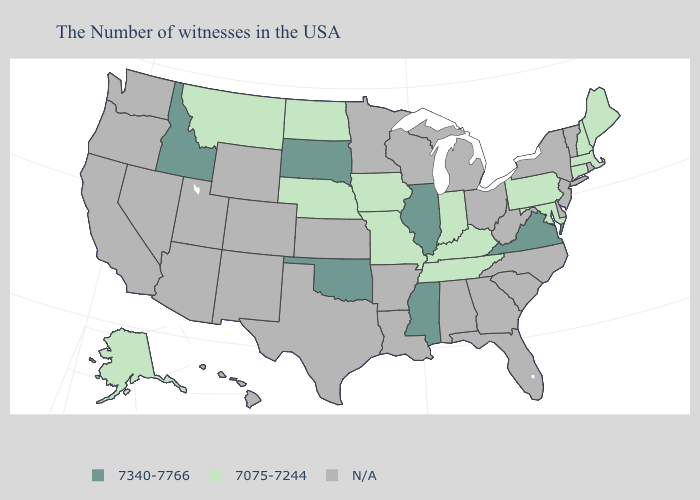What is the value of Vermont?
Keep it brief. N/A. Does the first symbol in the legend represent the smallest category?
Concise answer only. No. Name the states that have a value in the range N/A?
Write a very short answer. Rhode Island, Vermont, New York, New Jersey, Delaware, North Carolina, South Carolina, West Virginia, Ohio, Florida, Georgia, Michigan, Alabama, Wisconsin, Louisiana, Arkansas, Minnesota, Kansas, Texas, Wyoming, Colorado, New Mexico, Utah, Arizona, Nevada, California, Washington, Oregon, Hawaii. What is the highest value in the MidWest ?
Be succinct. 7340-7766. Does Montana have the lowest value in the West?
Concise answer only. Yes. Which states have the lowest value in the USA?
Quick response, please. Maine, Massachusetts, New Hampshire, Connecticut, Maryland, Pennsylvania, Kentucky, Indiana, Tennessee, Missouri, Iowa, Nebraska, North Dakota, Montana, Alaska. Which states have the lowest value in the USA?
Be succinct. Maine, Massachusetts, New Hampshire, Connecticut, Maryland, Pennsylvania, Kentucky, Indiana, Tennessee, Missouri, Iowa, Nebraska, North Dakota, Montana, Alaska. Which states have the lowest value in the South?
Short answer required. Maryland, Kentucky, Tennessee. What is the lowest value in the MidWest?
Write a very short answer. 7075-7244. What is the lowest value in the USA?
Keep it brief. 7075-7244. How many symbols are there in the legend?
Concise answer only. 3. Which states have the lowest value in the Northeast?
Be succinct. Maine, Massachusetts, New Hampshire, Connecticut, Pennsylvania. Name the states that have a value in the range 7075-7244?
Write a very short answer. Maine, Massachusetts, New Hampshire, Connecticut, Maryland, Pennsylvania, Kentucky, Indiana, Tennessee, Missouri, Iowa, Nebraska, North Dakota, Montana, Alaska. How many symbols are there in the legend?
Give a very brief answer. 3. 